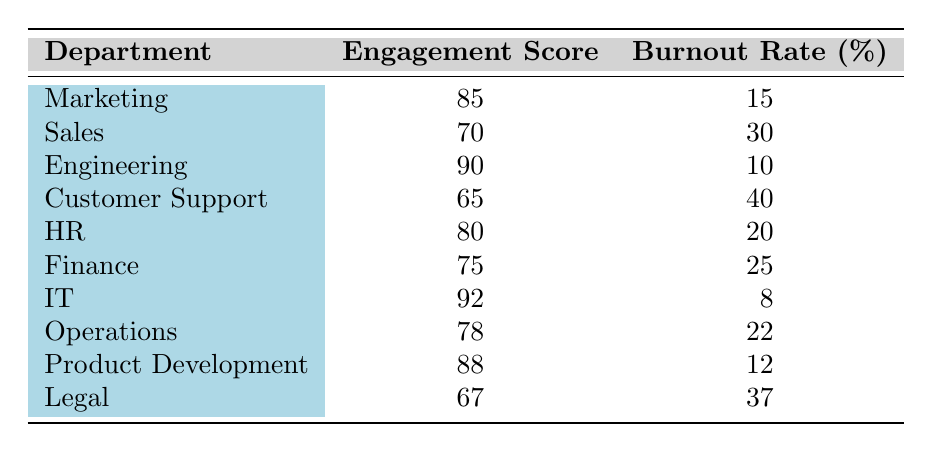What is the employee engagement score for the IT department? The table shows that the IT department has an employee engagement score listed as 92.
Answer: 92 Which department has the highest burnout rate? By looking at the burnout rates in the table, the Customer Support department has the highest rate at 40%.
Answer: 40% What is the average employee engagement score across all departments? Adding the engagement scores (85 + 70 + 90 + 65 + 80 + 75 + 92 + 78 + 88 + 67) gives a total of 820. There are 10 departments, so the average score is 820 divided by 10, which equals 82.
Answer: 82 Is there a department with both a high engagement score and a low burnout rate? Yes, looking at the table, the Engineering department has an engagement score of 90 and a burnout rate of 10%, which indicates both high engagement and low burnout.
Answer: Yes What is the difference in engagement score between the best and worst performing departments? The best performing department is IT with a score of 92, and the worst is Customer Support with a score of 65. The difference is 92 - 65 = 27.
Answer: 27 How many departments have a burnout rate below 20%? Referring to the table, the departments with a burnout rate below 20% are Marketing (15%), Engineering (10%), and IT (8%). This counts to 3 departments.
Answer: 3 What is the sum of the burnout rates of the Sales and Legal departments? The burnout rate for Sales is 30% and for Legal is 37%. Adding these together, we have 30 + 37 = 67%.
Answer: 67 Is it true that all departments with engagement scores above 80 have burnout rates below 20%? No, while the IT and Engineering departments both have scores over 80 with burnout rates below 20%, the HR department has a score of 80 but a burnout rate of 20%, which contradicts the statement.
Answer: No How many departments have engagement scores above the average score? The average engagement score is 82. The departments with scores above this are IT (92), Engineering (90), and Product Development (88), totaling 3 departments.
Answer: 3 